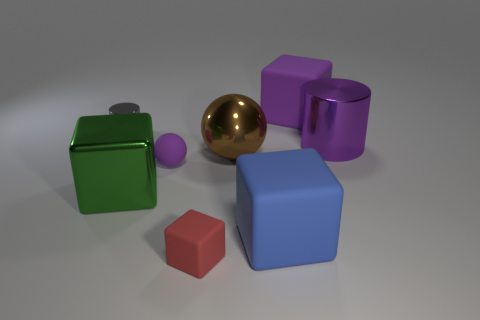How many other things are the same shape as the large blue object?
Make the answer very short. 3. Do the rubber block behind the big brown shiny ball and the big metallic cylinder have the same color?
Offer a terse response. Yes. How many other objects are there of the same size as the brown ball?
Keep it short and to the point. 4. Do the tiny purple thing and the red thing have the same material?
Ensure brevity in your answer.  Yes. The metallic cylinder that is to the left of the big metal thing on the left side of the metal sphere is what color?
Offer a terse response. Gray. There is a blue object that is the same shape as the big purple matte object; what is its size?
Offer a terse response. Large. Do the large cylinder and the tiny sphere have the same color?
Your answer should be very brief. Yes. There is a small object that is in front of the tiny purple object on the left side of the purple metal thing; how many rubber things are behind it?
Offer a terse response. 3. Is the number of green metallic blocks greater than the number of large things?
Offer a terse response. No. How many large blue blocks are there?
Make the answer very short. 1. 